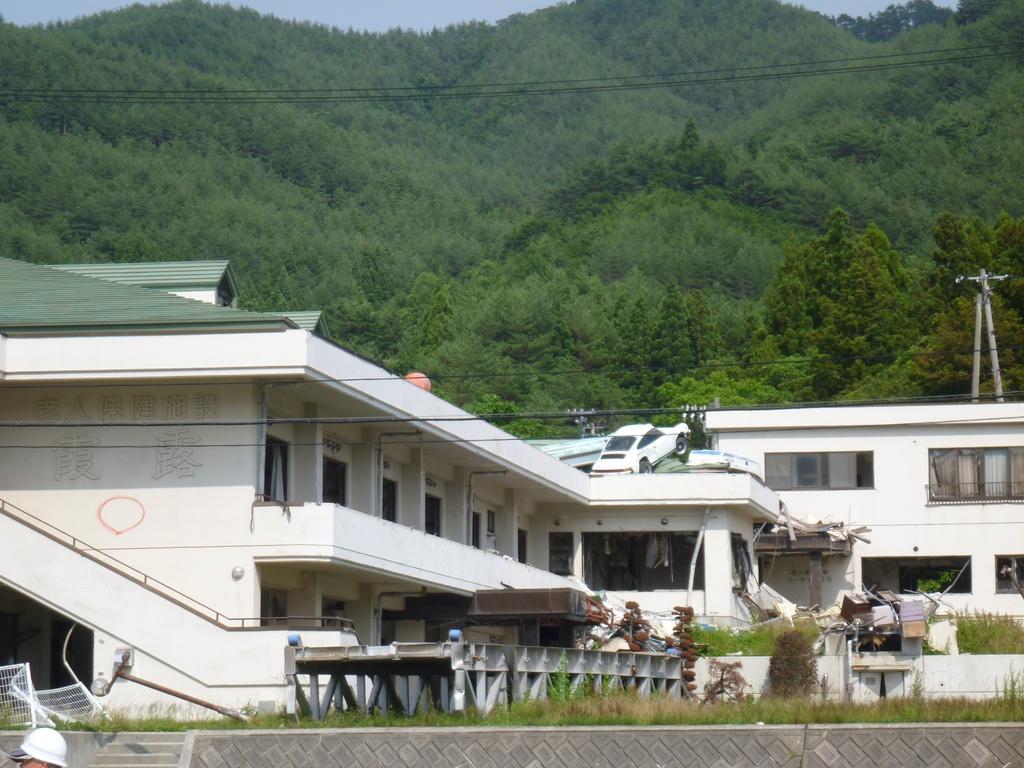In one or two sentences, can you explain what this image depicts? In this picture, we can see building with windows, ground with grass, stairs, railing, poles, wires, transformer, metallic objects, we can see a person head in the bottom left side of the picture, we can see mountains covered with trees and the sky. 